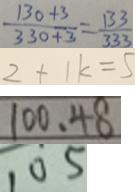<formula> <loc_0><loc_0><loc_500><loc_500>\frac { 1 3 0 + 3 } { 3 3 0 + 3 } = \frac { 1 3 3 } { 3 3 3 } 
 2 + 1 k = 5 
 1 0 0 . 4 8 
 1 0 5</formula> 